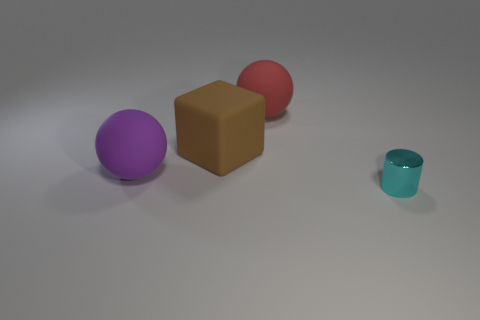Is the big cube the same color as the tiny object?
Your response must be concise. No. There is a object that is behind the rubber cube; is its shape the same as the metal thing on the right side of the big brown matte block?
Offer a terse response. No. How many other things are the same size as the cyan thing?
Give a very brief answer. 0. What is the size of the brown thing?
Your response must be concise. Large. Is the material of the large ball that is left of the block the same as the red object?
Make the answer very short. Yes. There is another thing that is the same shape as the red matte thing; what is its color?
Your response must be concise. Purple. There is a big ball on the left side of the large brown rubber object; is it the same color as the small thing?
Provide a succinct answer. No. There is a red rubber thing; are there any balls behind it?
Offer a terse response. No. What is the color of the object that is both behind the purple ball and on the left side of the big red thing?
Provide a short and direct response. Brown. How big is the ball behind the large rubber sphere that is left of the big red ball?
Offer a very short reply. Large. 